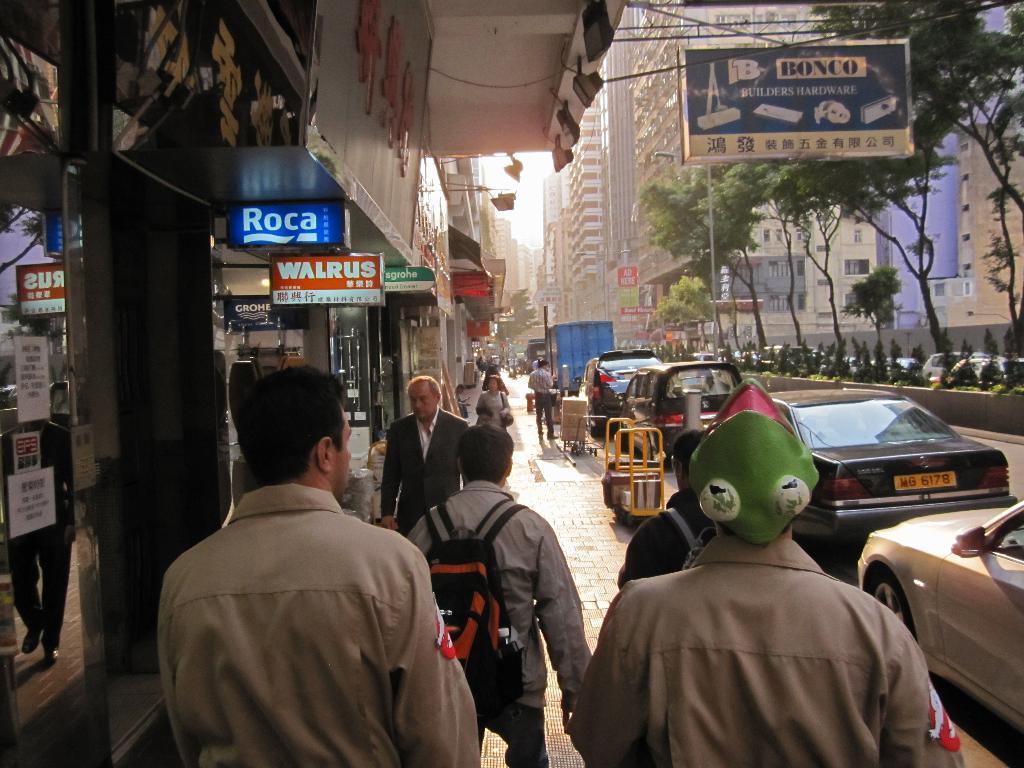In one or two sentences, can you explain what this image depicts? In this image we can see a group of people and some vehicles on the ground. We can also see some buildings with windows, the sign boards with some text on them, some plants, a group of trees, poles and the sky. 